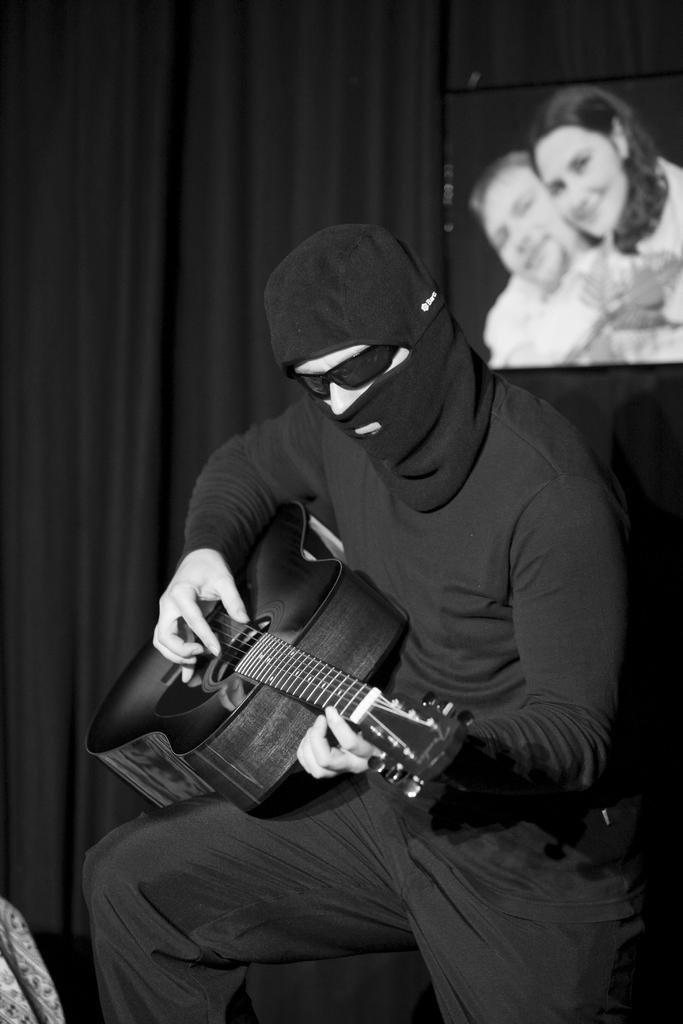What is the man in the image doing? The man is playing a guitar in the image. What object is present in the image that is related to photography? There is a photo frame in the image. What type of window treatment can be seen in the image? There are curtains in the image. What type of bushes can be seen growing around the man in the image? There are no bushes visible in the image; it is focused on the man playing the guitar and the surrounding objects. 